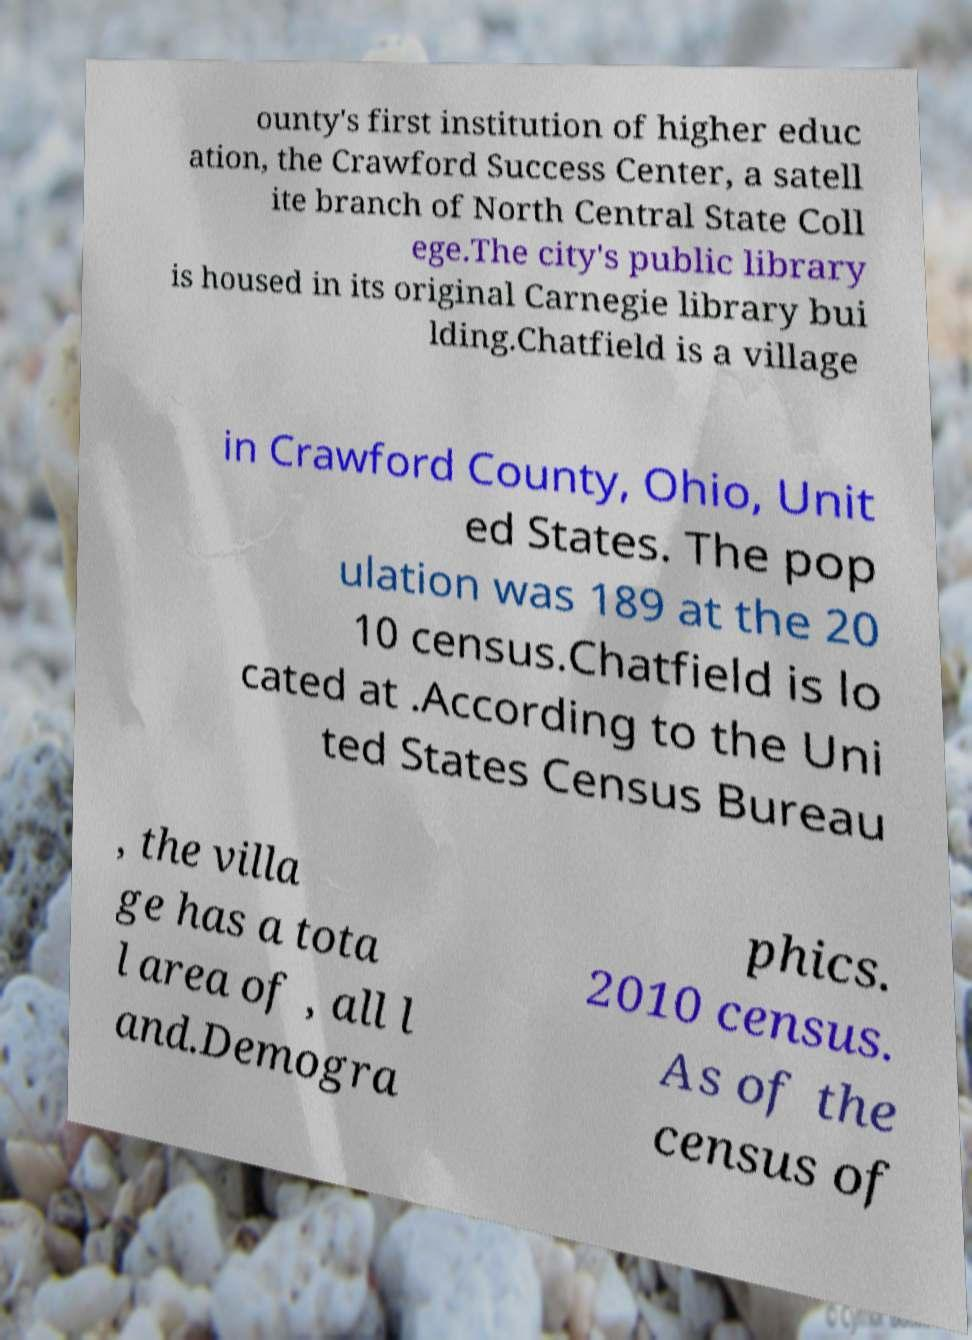I need the written content from this picture converted into text. Can you do that? ounty's first institution of higher educ ation, the Crawford Success Center, a satell ite branch of North Central State Coll ege.The city's public library is housed in its original Carnegie library bui lding.Chatfield is a village in Crawford County, Ohio, Unit ed States. The pop ulation was 189 at the 20 10 census.Chatfield is lo cated at .According to the Uni ted States Census Bureau , the villa ge has a tota l area of , all l and.Demogra phics. 2010 census. As of the census of 